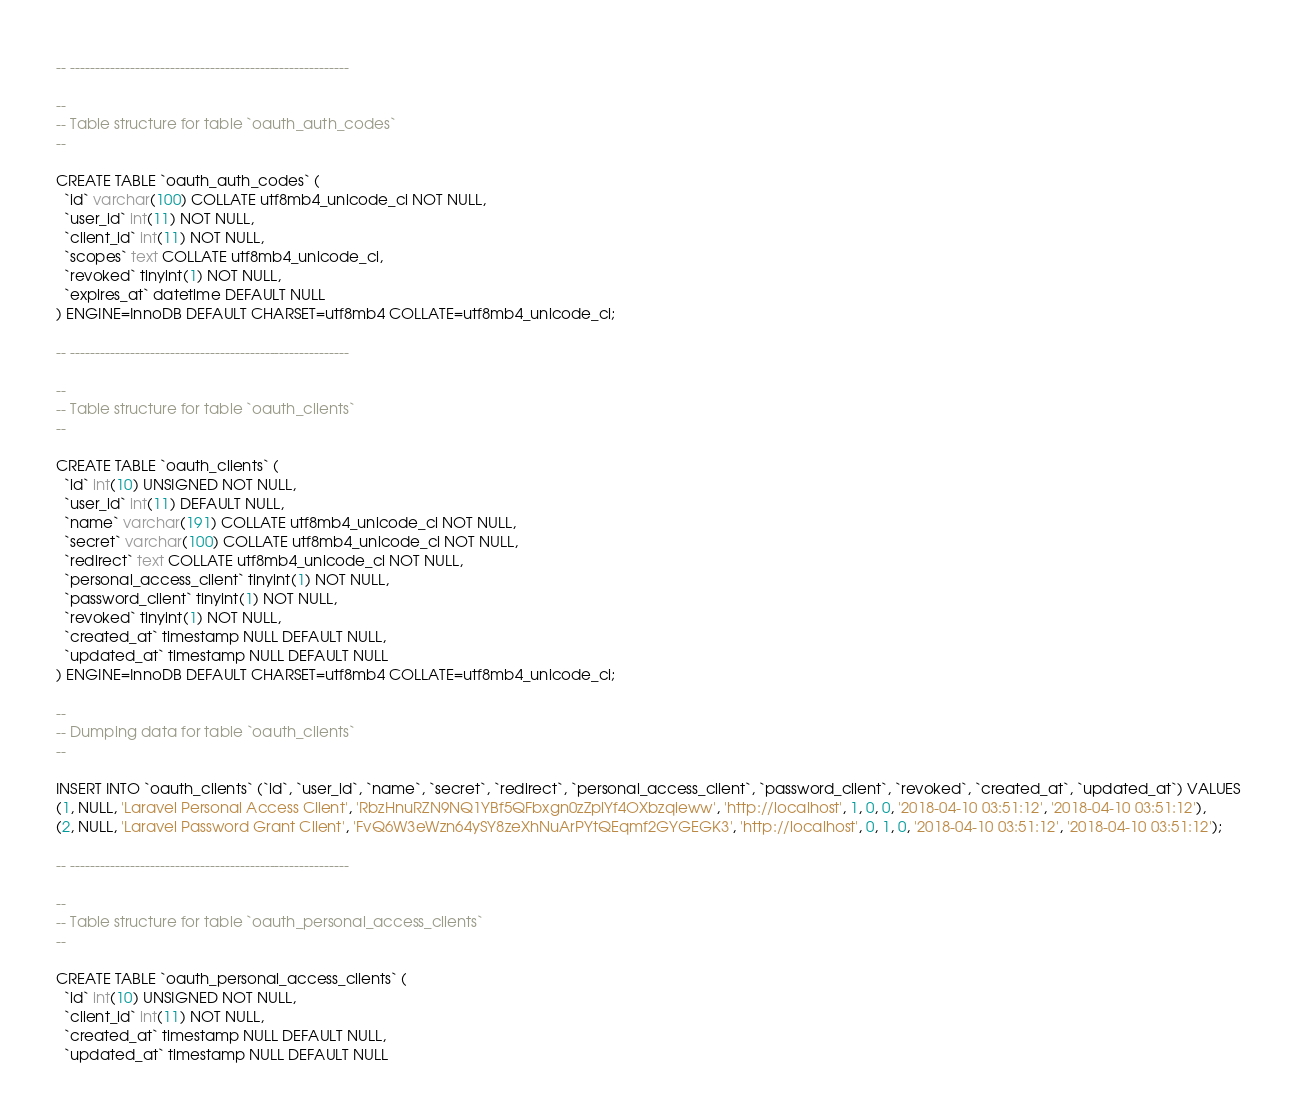Convert code to text. <code><loc_0><loc_0><loc_500><loc_500><_SQL_>-- --------------------------------------------------------

--
-- Table structure for table `oauth_auth_codes`
--

CREATE TABLE `oauth_auth_codes` (
  `id` varchar(100) COLLATE utf8mb4_unicode_ci NOT NULL,
  `user_id` int(11) NOT NULL,
  `client_id` int(11) NOT NULL,
  `scopes` text COLLATE utf8mb4_unicode_ci,
  `revoked` tinyint(1) NOT NULL,
  `expires_at` datetime DEFAULT NULL
) ENGINE=InnoDB DEFAULT CHARSET=utf8mb4 COLLATE=utf8mb4_unicode_ci;

-- --------------------------------------------------------

--
-- Table structure for table `oauth_clients`
--

CREATE TABLE `oauth_clients` (
  `id` int(10) UNSIGNED NOT NULL,
  `user_id` int(11) DEFAULT NULL,
  `name` varchar(191) COLLATE utf8mb4_unicode_ci NOT NULL,
  `secret` varchar(100) COLLATE utf8mb4_unicode_ci NOT NULL,
  `redirect` text COLLATE utf8mb4_unicode_ci NOT NULL,
  `personal_access_client` tinyint(1) NOT NULL,
  `password_client` tinyint(1) NOT NULL,
  `revoked` tinyint(1) NOT NULL,
  `created_at` timestamp NULL DEFAULT NULL,
  `updated_at` timestamp NULL DEFAULT NULL
) ENGINE=InnoDB DEFAULT CHARSET=utf8mb4 COLLATE=utf8mb4_unicode_ci;

--
-- Dumping data for table `oauth_clients`
--

INSERT INTO `oauth_clients` (`id`, `user_id`, `name`, `secret`, `redirect`, `personal_access_client`, `password_client`, `revoked`, `created_at`, `updated_at`) VALUES
(1, NULL, 'Laravel Personal Access Client', 'RbzHnuRZN9NQ1YBf5QFbxgn0zZplYf4OXbzqieww', 'http://localhost', 1, 0, 0, '2018-04-10 03:51:12', '2018-04-10 03:51:12'),
(2, NULL, 'Laravel Password Grant Client', 'FvQ6W3eWzn64ySY8zeXhNuArPYtQEqmf2GYGEGK3', 'http://localhost', 0, 1, 0, '2018-04-10 03:51:12', '2018-04-10 03:51:12');

-- --------------------------------------------------------

--
-- Table structure for table `oauth_personal_access_clients`
--

CREATE TABLE `oauth_personal_access_clients` (
  `id` int(10) UNSIGNED NOT NULL,
  `client_id` int(11) NOT NULL,
  `created_at` timestamp NULL DEFAULT NULL,
  `updated_at` timestamp NULL DEFAULT NULL</code> 